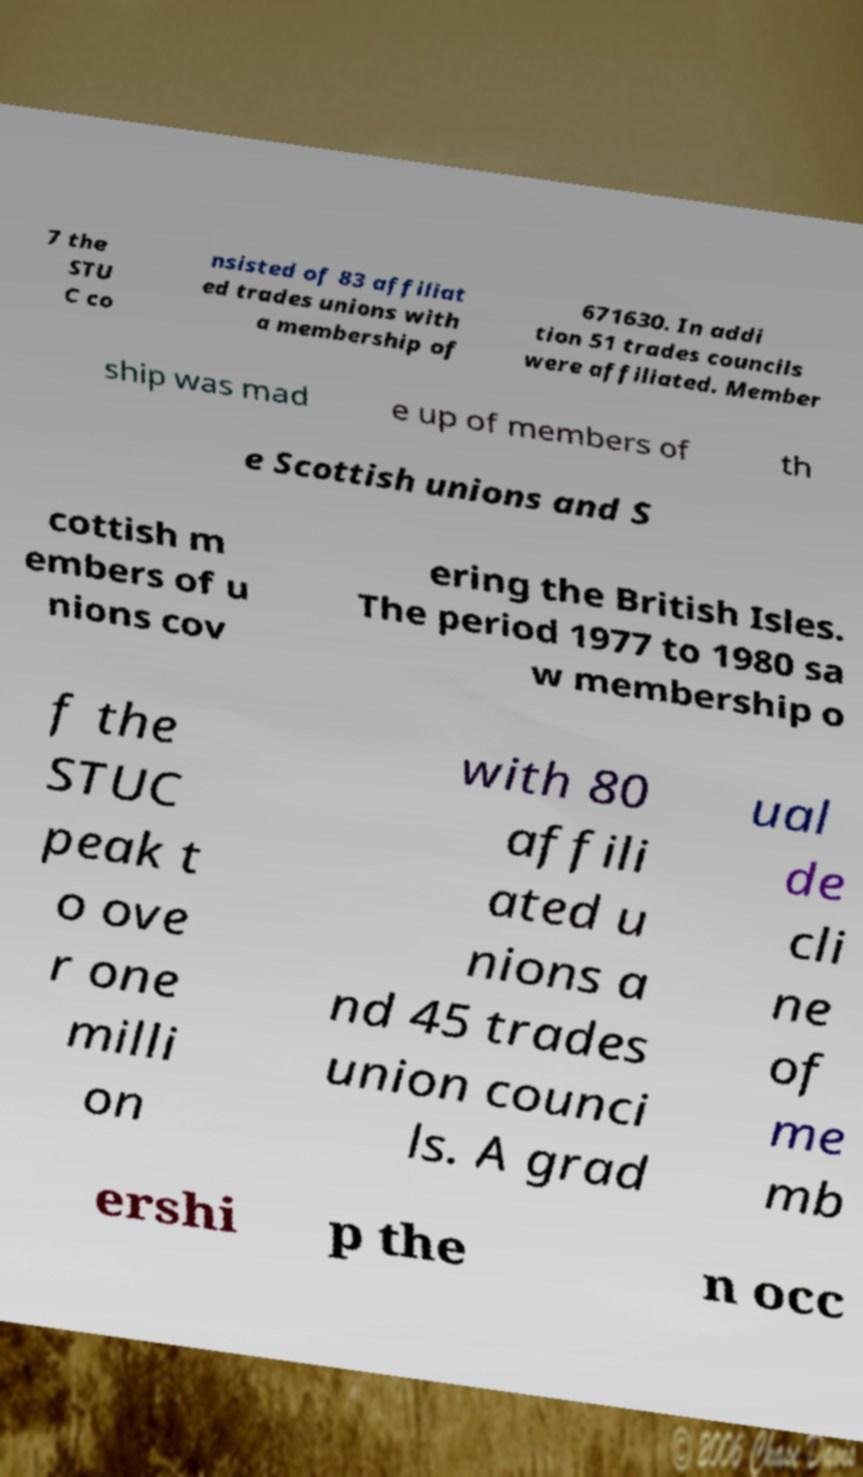Please identify and transcribe the text found in this image. 7 the STU C co nsisted of 83 affiliat ed trades unions with a membership of 671630. In addi tion 51 trades councils were affiliated. Member ship was mad e up of members of th e Scottish unions and S cottish m embers of u nions cov ering the British Isles. The period 1977 to 1980 sa w membership o f the STUC peak t o ove r one milli on with 80 affili ated u nions a nd 45 trades union counci ls. A grad ual de cli ne of me mb ershi p the n occ 